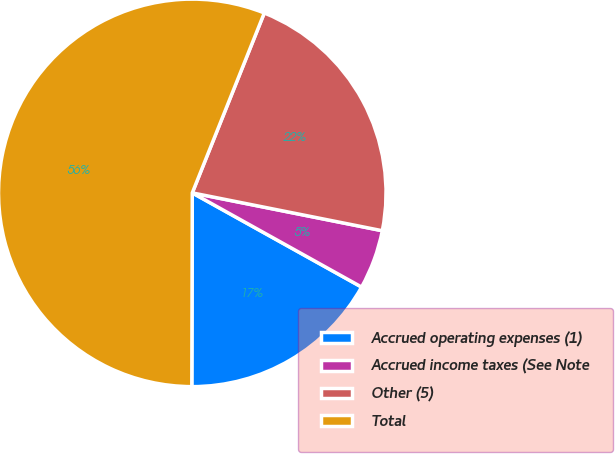Convert chart. <chart><loc_0><loc_0><loc_500><loc_500><pie_chart><fcel>Accrued operating expenses (1)<fcel>Accrued income taxes (See Note<fcel>Other (5)<fcel>Total<nl><fcel>16.96%<fcel>4.95%<fcel>22.07%<fcel>56.02%<nl></chart> 